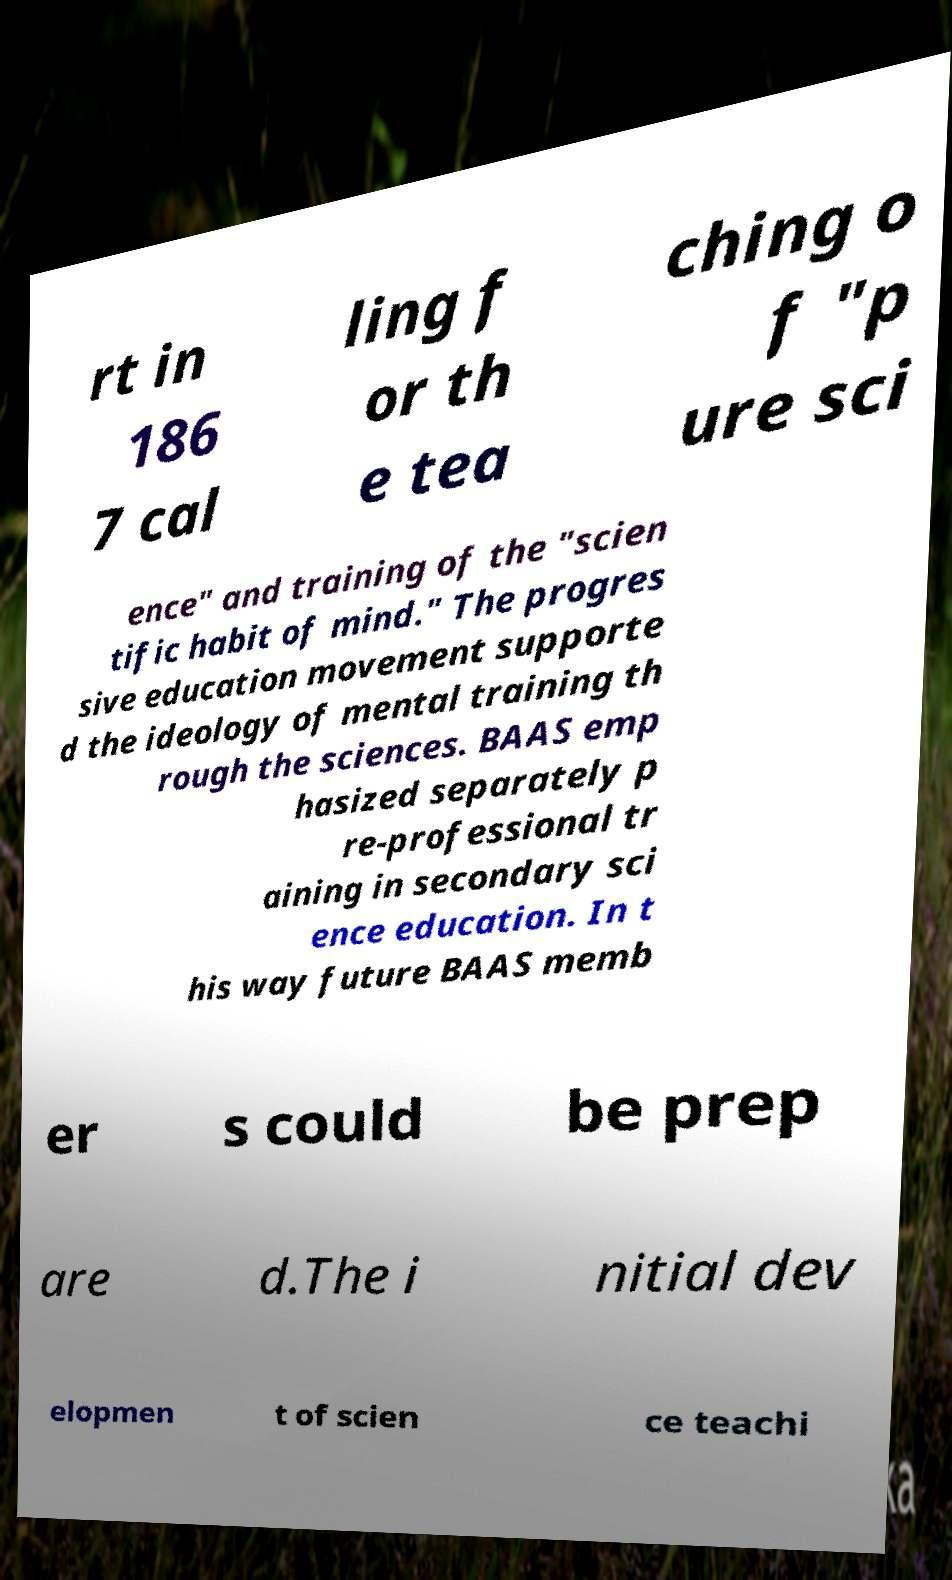I need the written content from this picture converted into text. Can you do that? rt in 186 7 cal ling f or th e tea ching o f "p ure sci ence" and training of the "scien tific habit of mind." The progres sive education movement supporte d the ideology of mental training th rough the sciences. BAAS emp hasized separately p re-professional tr aining in secondary sci ence education. In t his way future BAAS memb er s could be prep are d.The i nitial dev elopmen t of scien ce teachi 